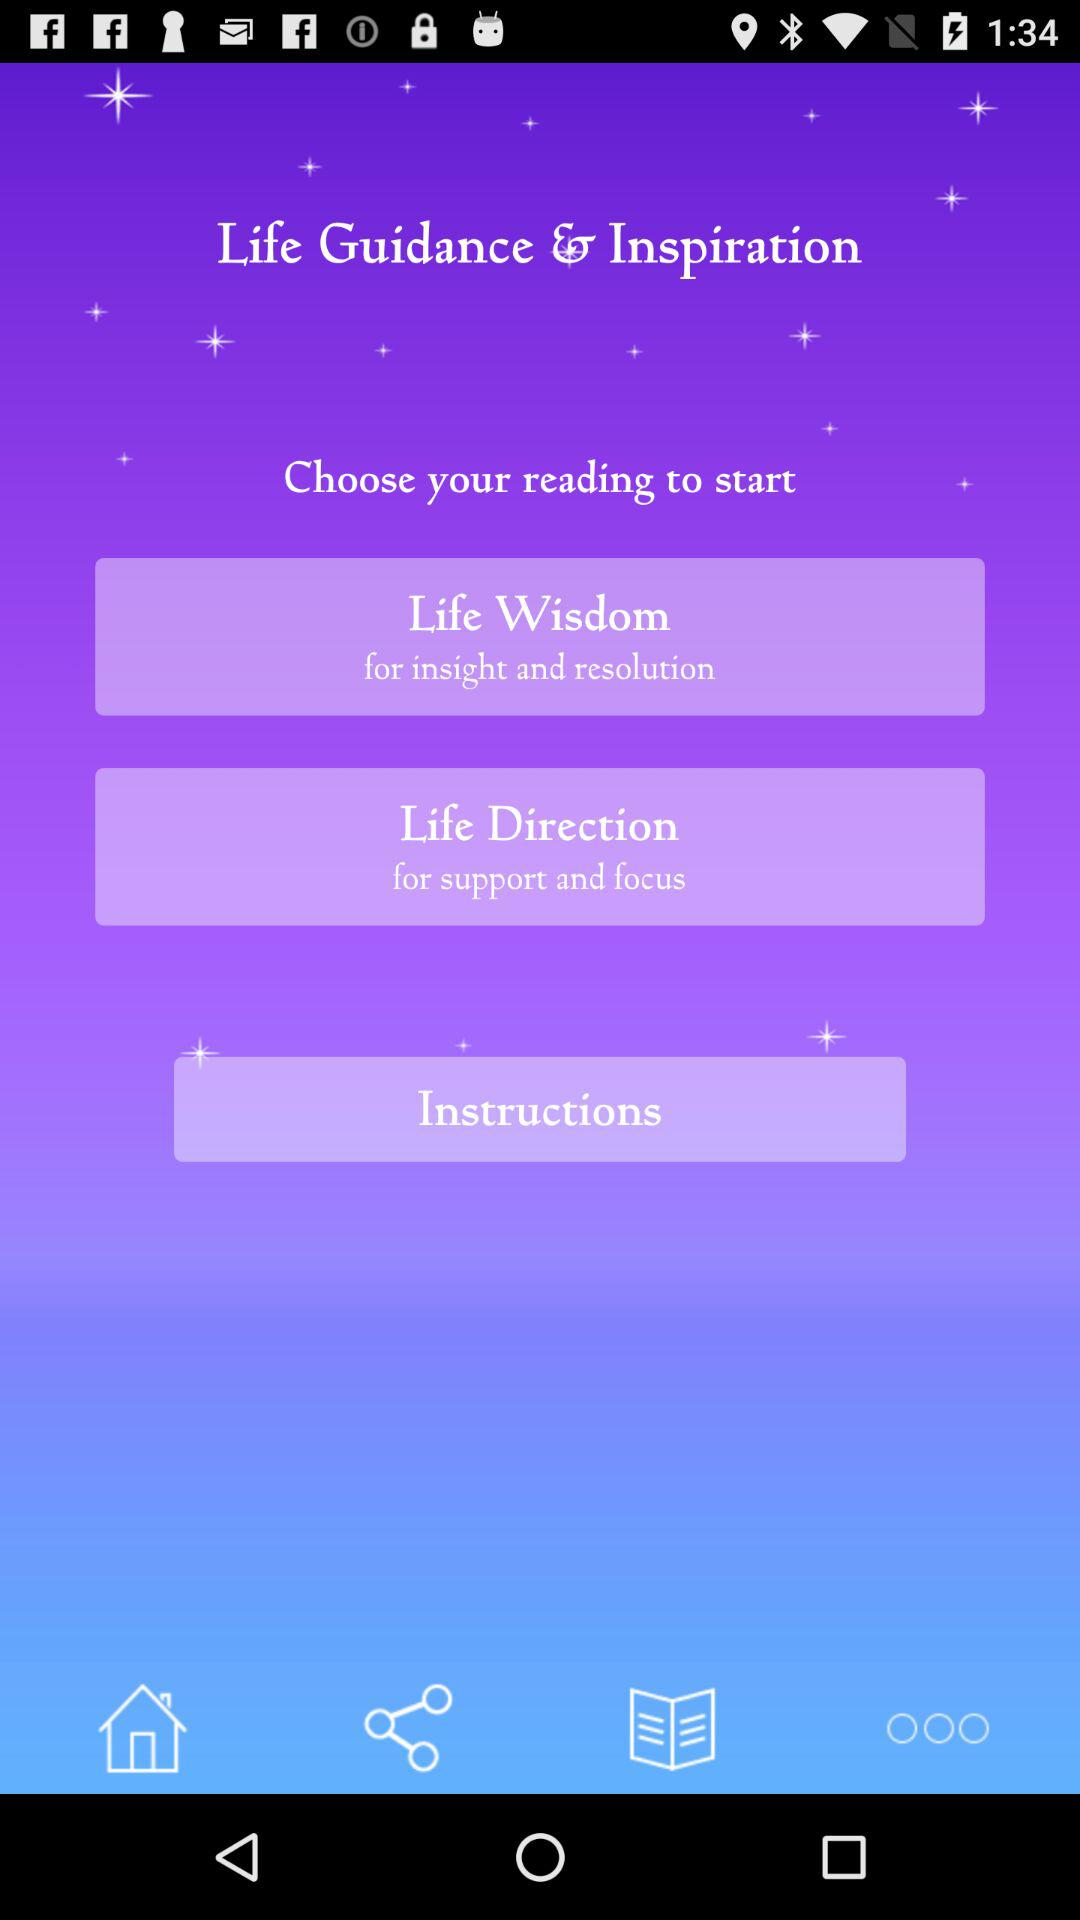What is the name of the application? The name of the application is "Life Guidance & Inspiration". 